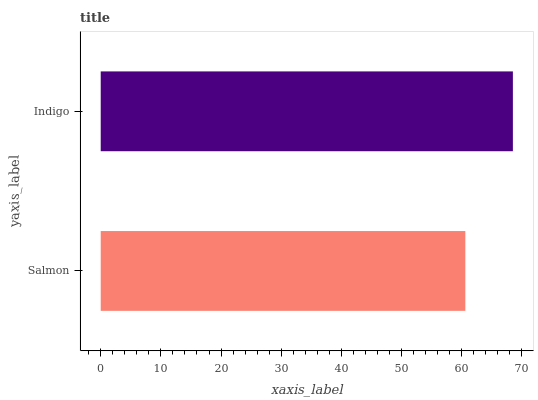Is Salmon the minimum?
Answer yes or no. Yes. Is Indigo the maximum?
Answer yes or no. Yes. Is Indigo the minimum?
Answer yes or no. No. Is Indigo greater than Salmon?
Answer yes or no. Yes. Is Salmon less than Indigo?
Answer yes or no. Yes. Is Salmon greater than Indigo?
Answer yes or no. No. Is Indigo less than Salmon?
Answer yes or no. No. Is Indigo the high median?
Answer yes or no. Yes. Is Salmon the low median?
Answer yes or no. Yes. Is Salmon the high median?
Answer yes or no. No. Is Indigo the low median?
Answer yes or no. No. 